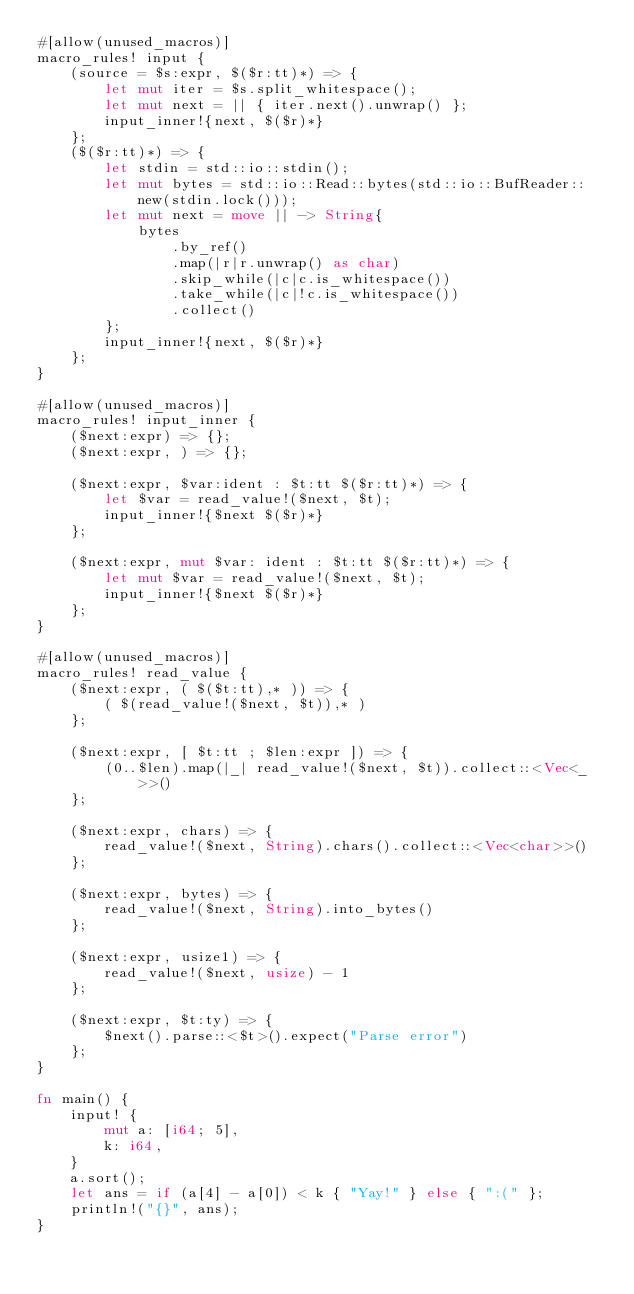<code> <loc_0><loc_0><loc_500><loc_500><_Rust_>#[allow(unused_macros)]
macro_rules! input {
    (source = $s:expr, $($r:tt)*) => {
        let mut iter = $s.split_whitespace();
        let mut next = || { iter.next().unwrap() };
        input_inner!{next, $($r)*}
    };
    ($($r:tt)*) => {
        let stdin = std::io::stdin();
        let mut bytes = std::io::Read::bytes(std::io::BufReader::new(stdin.lock()));
        let mut next = move || -> String{
            bytes
                .by_ref()
                .map(|r|r.unwrap() as char)
                .skip_while(|c|c.is_whitespace())
                .take_while(|c|!c.is_whitespace())
                .collect()
        };
        input_inner!{next, $($r)*}
    };
}

#[allow(unused_macros)]
macro_rules! input_inner {
    ($next:expr) => {};
    ($next:expr, ) => {};

    ($next:expr, $var:ident : $t:tt $($r:tt)*) => {
        let $var = read_value!($next, $t);
        input_inner!{$next $($r)*}
    };

    ($next:expr, mut $var: ident : $t:tt $($r:tt)*) => {
        let mut $var = read_value!($next, $t);
        input_inner!{$next $($r)*}
    };
}

#[allow(unused_macros)]
macro_rules! read_value {
    ($next:expr, ( $($t:tt),* )) => {
        ( $(read_value!($next, $t)),* )
    };

    ($next:expr, [ $t:tt ; $len:expr ]) => {
        (0..$len).map(|_| read_value!($next, $t)).collect::<Vec<_>>()
    };

    ($next:expr, chars) => {
        read_value!($next, String).chars().collect::<Vec<char>>()
    };

    ($next:expr, bytes) => {
        read_value!($next, String).into_bytes()
    };

    ($next:expr, usize1) => {
        read_value!($next, usize) - 1
    };

    ($next:expr, $t:ty) => {
        $next().parse::<$t>().expect("Parse error")
    };
}

fn main() {
    input! {
        mut a: [i64; 5],
        k: i64,
    }
    a.sort();
    let ans = if (a[4] - a[0]) < k { "Yay!" } else { ":(" };
    println!("{}", ans);
}</code> 